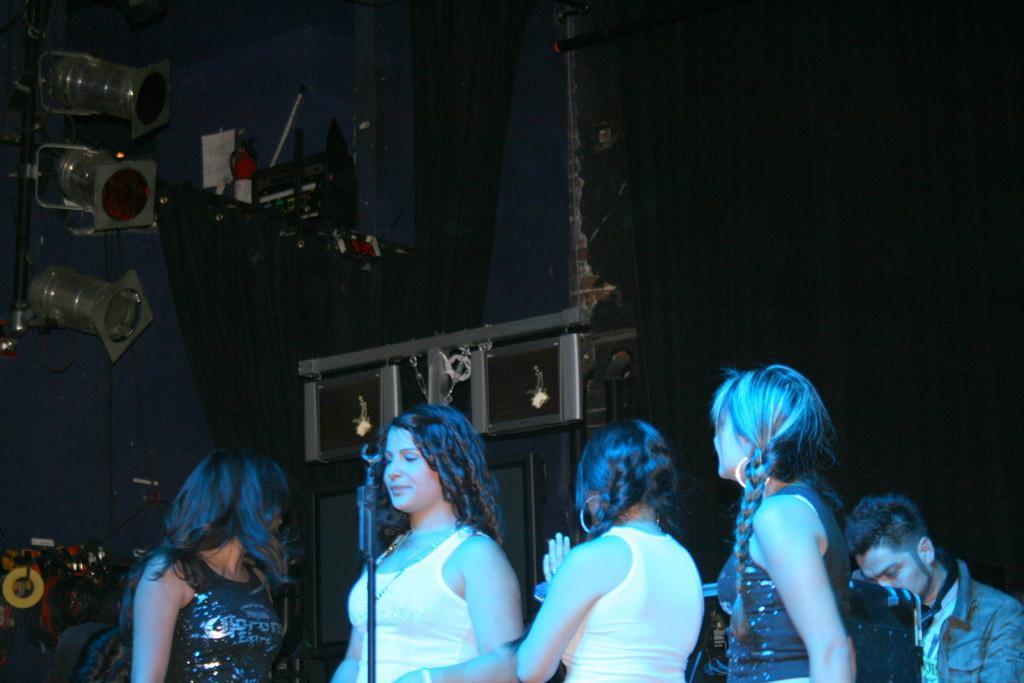Please provide a concise description of this image. In this image we can see five persons. In front of the persons we can see a mic with a stand. Behind the persons we can see an object. On the left side, we can see lights attached to a stand. In the background, we can see the curtains and few objects attached to the wall. 